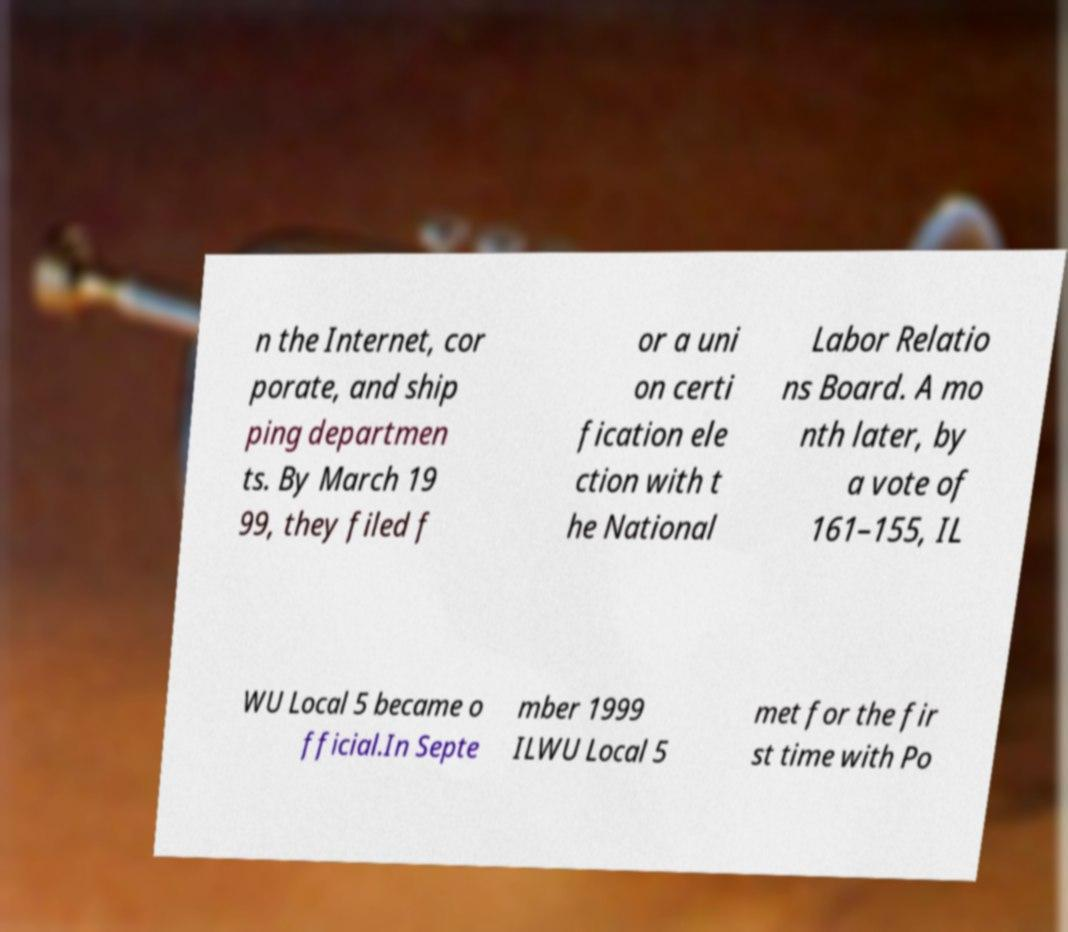What messages or text are displayed in this image? I need them in a readable, typed format. n the Internet, cor porate, and ship ping departmen ts. By March 19 99, they filed f or a uni on certi fication ele ction with t he National Labor Relatio ns Board. A mo nth later, by a vote of 161–155, IL WU Local 5 became o fficial.In Septe mber 1999 ILWU Local 5 met for the fir st time with Po 